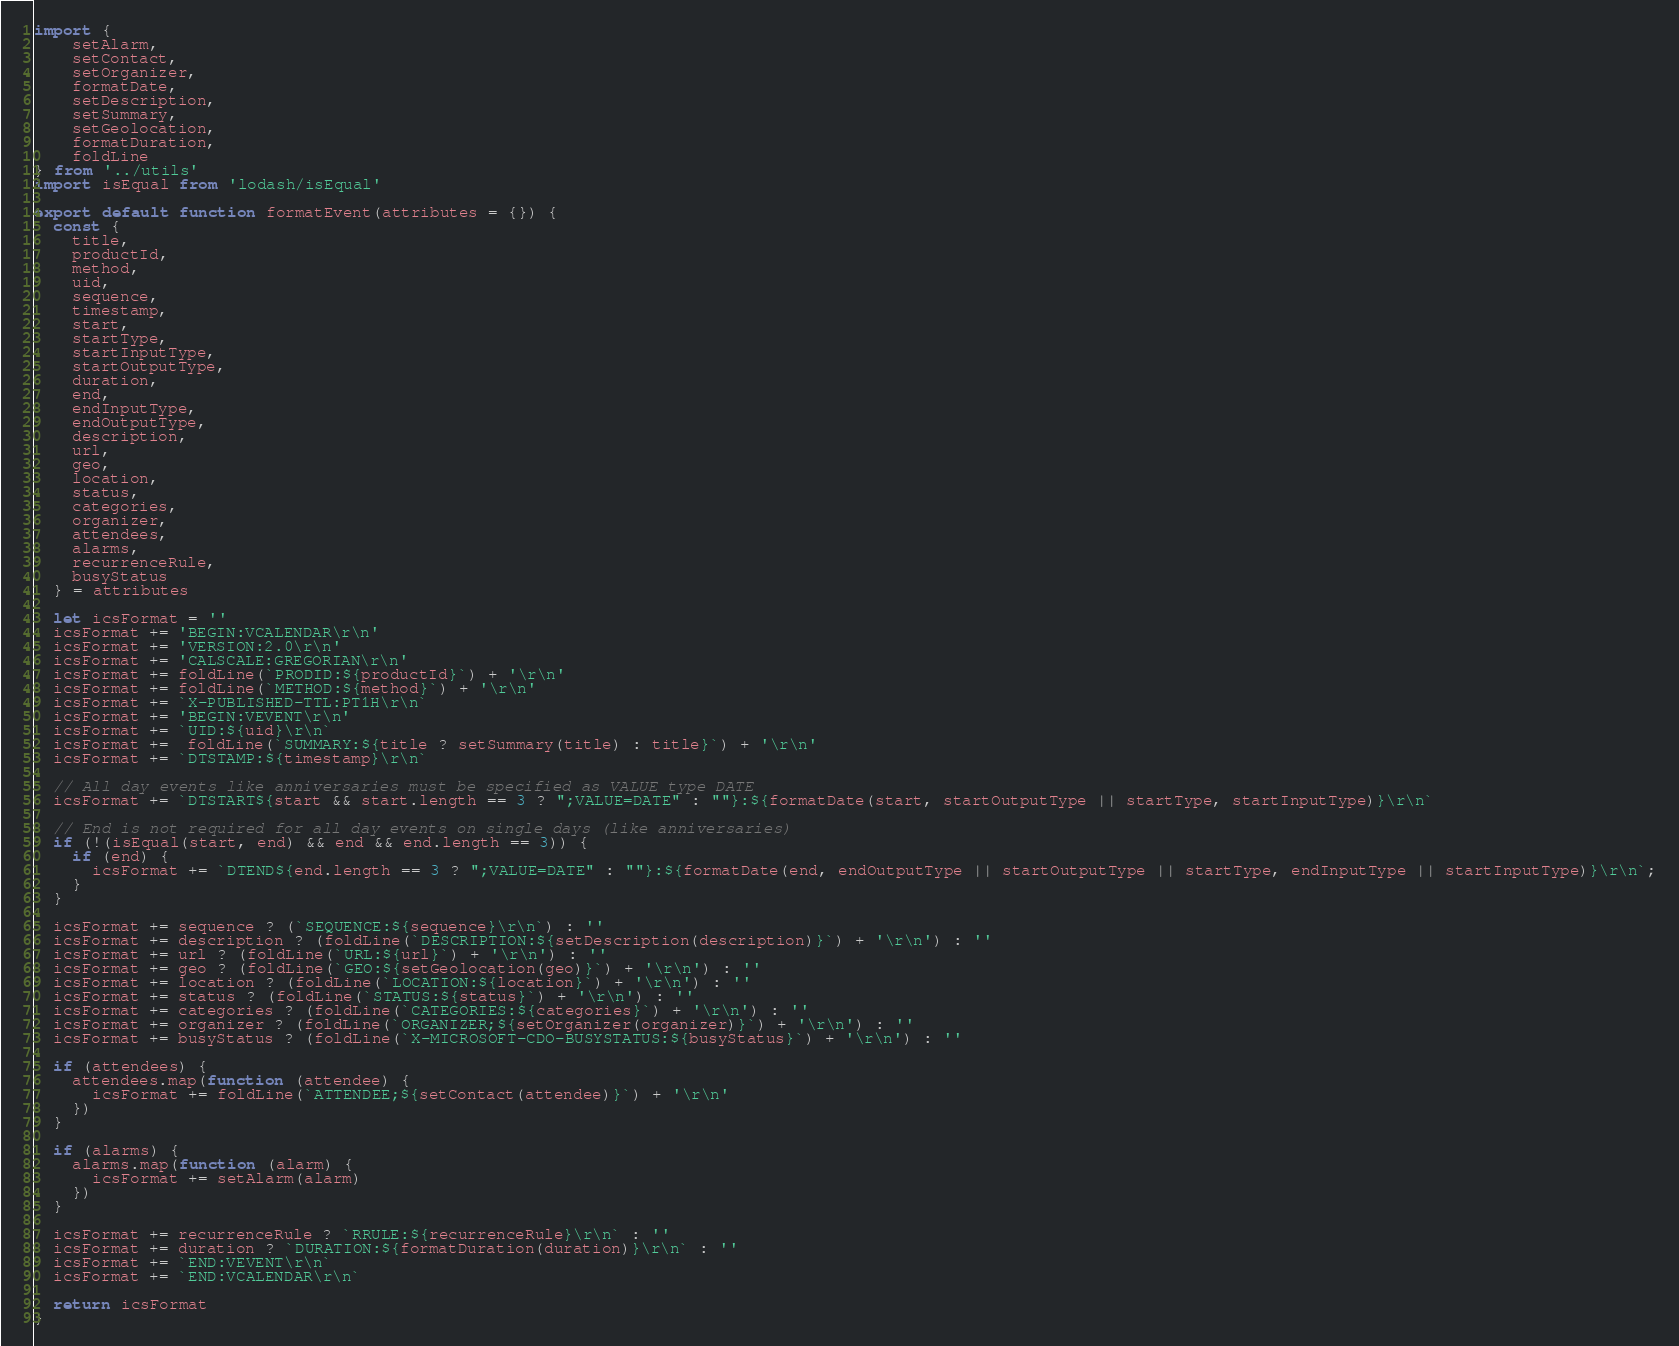<code> <loc_0><loc_0><loc_500><loc_500><_JavaScript_>import {
    setAlarm,
    setContact,
    setOrganizer,
    formatDate,
    setDescription,
    setSummary,
    setGeolocation,
    formatDuration,
    foldLine
} from '../utils'
import isEqual from 'lodash/isEqual'

export default function formatEvent(attributes = {}) {
  const {
    title,
    productId,
    method,
    uid,
    sequence,
    timestamp,
    start,
    startType,
    startInputType,
    startOutputType,
    duration,
    end,
    endInputType,
    endOutputType,
    description,
    url,
    geo,
    location,
    status,
    categories,
    organizer,
    attendees,
    alarms,
    recurrenceRule,
    busyStatus
  } = attributes

  let icsFormat = ''
  icsFormat += 'BEGIN:VCALENDAR\r\n'
  icsFormat += 'VERSION:2.0\r\n'
  icsFormat += 'CALSCALE:GREGORIAN\r\n'
  icsFormat += foldLine(`PRODID:${productId}`) + '\r\n'
  icsFormat += foldLine(`METHOD:${method}`) + '\r\n'
  icsFormat += `X-PUBLISHED-TTL:PT1H\r\n`
  icsFormat += 'BEGIN:VEVENT\r\n'
  icsFormat += `UID:${uid}\r\n`
  icsFormat +=  foldLine(`SUMMARY:${title ? setSummary(title) : title}`) + '\r\n'
  icsFormat += `DTSTAMP:${timestamp}\r\n`

  // All day events like anniversaries must be specified as VALUE type DATE
  icsFormat += `DTSTART${start && start.length == 3 ? ";VALUE=DATE" : ""}:${formatDate(start, startOutputType || startType, startInputType)}\r\n`

  // End is not required for all day events on single days (like anniversaries)
  if (!(isEqual(start, end) && end && end.length == 3)) {
    if (end) {
      icsFormat += `DTEND${end.length == 3 ? ";VALUE=DATE" : ""}:${formatDate(end, endOutputType || startOutputType || startType, endInputType || startInputType)}\r\n`;
    }
  }

  icsFormat += sequence ? (`SEQUENCE:${sequence}\r\n`) : ''
  icsFormat += description ? (foldLine(`DESCRIPTION:${setDescription(description)}`) + '\r\n') : ''
  icsFormat += url ? (foldLine(`URL:${url}`) + '\r\n') : ''
  icsFormat += geo ? (foldLine(`GEO:${setGeolocation(geo)}`) + '\r\n') : ''
  icsFormat += location ? (foldLine(`LOCATION:${location}`) + '\r\n') : ''
  icsFormat += status ? (foldLine(`STATUS:${status}`) + '\r\n') : ''
  icsFormat += categories ? (foldLine(`CATEGORIES:${categories}`) + '\r\n') : ''
  icsFormat += organizer ? (foldLine(`ORGANIZER;${setOrganizer(organizer)}`) + '\r\n') : ''
  icsFormat += busyStatus ? (foldLine(`X-MICROSOFT-CDO-BUSYSTATUS:${busyStatus}`) + '\r\n') : ''

  if (attendees) {
    attendees.map(function (attendee) {
      icsFormat += foldLine(`ATTENDEE;${setContact(attendee)}`) + '\r\n'
    })
  }
  
  if (alarms) {
    alarms.map(function (alarm) {
      icsFormat += setAlarm(alarm)
    })
  }

  icsFormat += recurrenceRule ? `RRULE:${recurrenceRule}\r\n` : ''
  icsFormat += duration ? `DURATION:${formatDuration(duration)}\r\n` : ''
  icsFormat += `END:VEVENT\r\n`
  icsFormat += `END:VCALENDAR\r\n`

  return icsFormat
}
</code> 